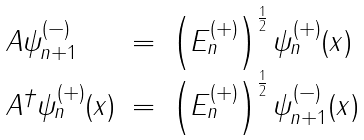<formula> <loc_0><loc_0><loc_500><loc_500>\begin{array} { l c l } A \psi _ { n + 1 } ^ { ( - ) } & = & \left ( E _ { n } ^ { ( + ) } \right ) ^ { \frac { 1 } { 2 } } \psi _ { n } ^ { ( + ) } ( x ) \\ A ^ { \dagger } \psi _ { n } ^ { ( + ) } ( x ) & = & \left ( E _ { n } ^ { ( + ) } \right ) ^ { \frac { 1 } { 2 } } \psi _ { n + 1 } ^ { ( - ) } ( x ) \end{array}</formula> 